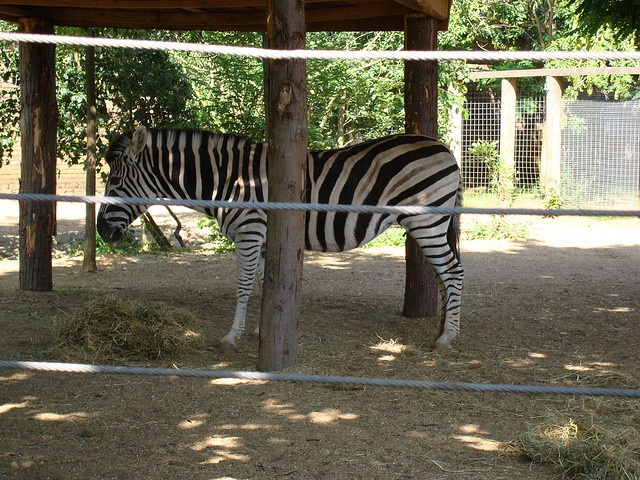Describe the objects in this image and their specific colors. I can see a zebra in maroon, black, gray, and darkgray tones in this image. 